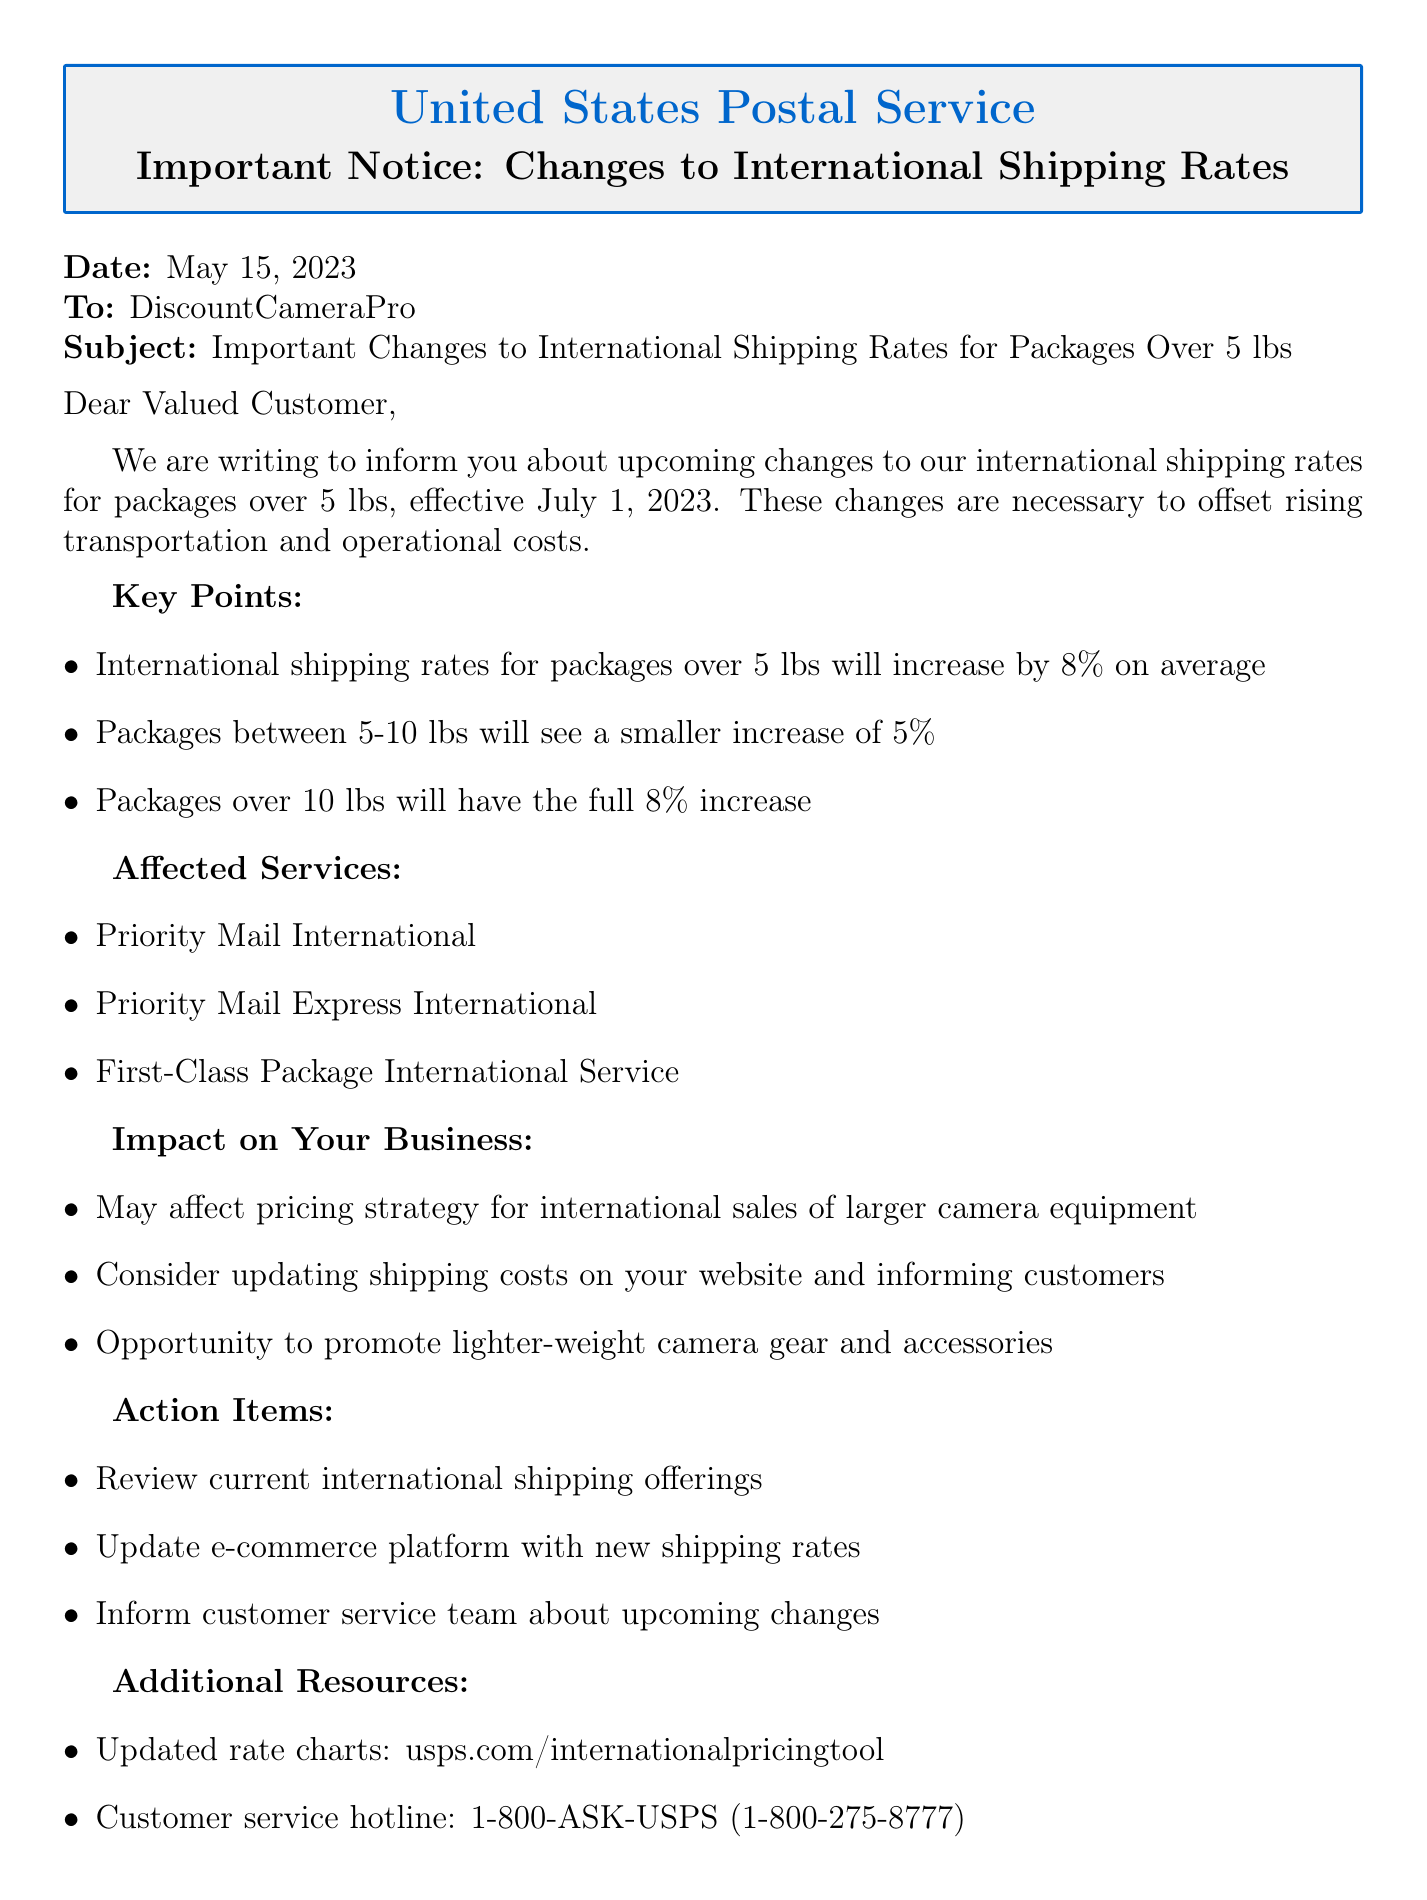What is the sender's name? The sender's name is the organization issuing the document, which is mentioned at the top.
Answer: United States Postal Service What is the effective date for the changes? The effective date for the changes is clearly stated in the document.
Answer: July 1, 2023 What percentage will international shipping rates increase for packages over 5 lbs? The percentage increase is outlined in the key points section of the document.
Answer: 8% Which services are affected by the new rates? The affected services are listed in an itemized format in the document.
Answer: Priority Mail International, Priority Mail Express International, First-Class Package International Service What kind of packages will see a 5% increase? The type of packages that will see a different increase percentage is specified in the key points.
Answer: Packages between 5-10 lbs What should be updated on the e-commerce platform? An action item specifies what needs to be updated related to shipping rates.
Answer: New shipping rates How might this change impact pricing strategy? The impact on business section explains the potential effects on pricing strategies.
Answer: May affect pricing strategy for international sales of larger camera equipment What resource is provided for updated rate charts? The resource for updated rate charts is stated in the additional resources section.
Answer: usps.com/internationalpricingtool 